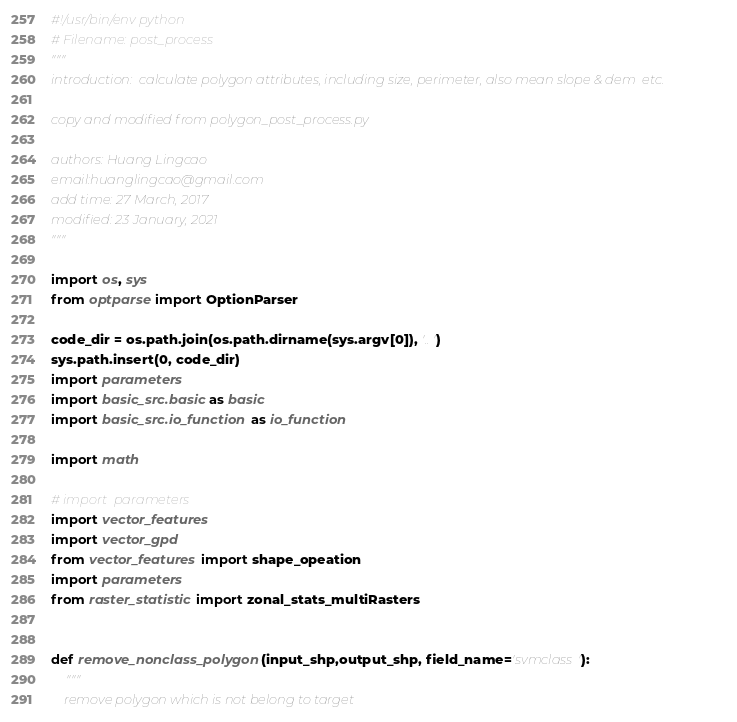<code> <loc_0><loc_0><loc_500><loc_500><_Python_>#!/usr/bin/env python
# Filename: post_process 
"""
introduction:  calculate polygon attributes, including size, perimeter, also mean slope & dem  etc.

copy and modified from polygon_post_process.py

authors: Huang Lingcao
email:huanglingcao@gmail.com
add time: 27 March, 2017
modified: 23 January, 2021
"""

import os, sys
from optparse import OptionParser

code_dir = os.path.join(os.path.dirname(sys.argv[0]), '..')
sys.path.insert(0, code_dir)
import parameters
import basic_src.basic as basic
import basic_src.io_function as io_function

import math

# import  parameters
import vector_features
import vector_gpd
from vector_features import shape_opeation
import parameters
from raster_statistic import zonal_stats_multiRasters


def remove_nonclass_polygon(input_shp,output_shp, field_name='svmclass'):
    """
    remove polygon which is not belong to target</code> 